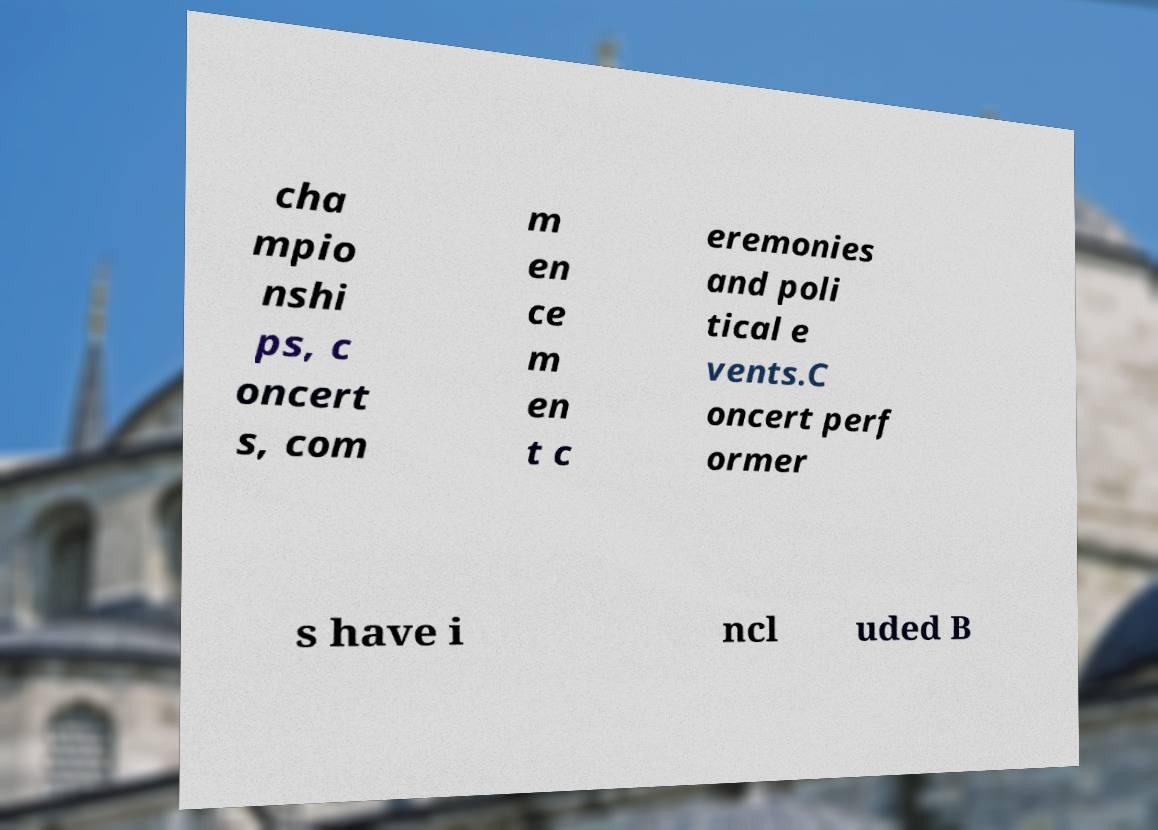Could you assist in decoding the text presented in this image and type it out clearly? cha mpio nshi ps, c oncert s, com m en ce m en t c eremonies and poli tical e vents.C oncert perf ormer s have i ncl uded B 